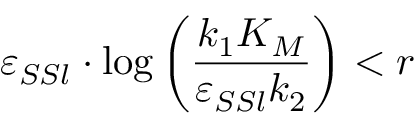<formula> <loc_0><loc_0><loc_500><loc_500>\varepsilon _ { S S l } \cdot \log \left ( \frac { k _ { 1 } K _ { M } } { \varepsilon _ { S S l } k _ { 2 } } \right ) < r</formula> 